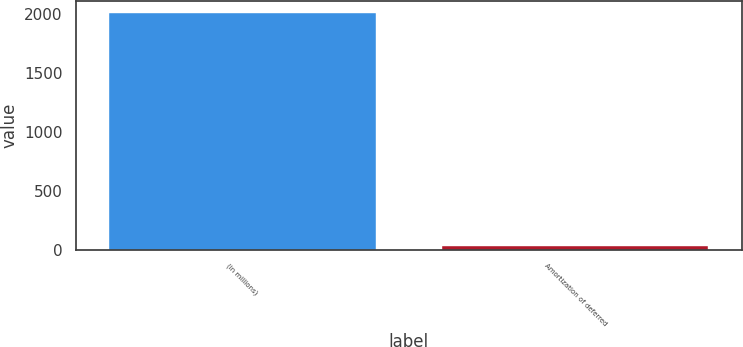<chart> <loc_0><loc_0><loc_500><loc_500><bar_chart><fcel>(in millions)<fcel>Amortization of deferred<nl><fcel>2011<fcel>34<nl></chart> 